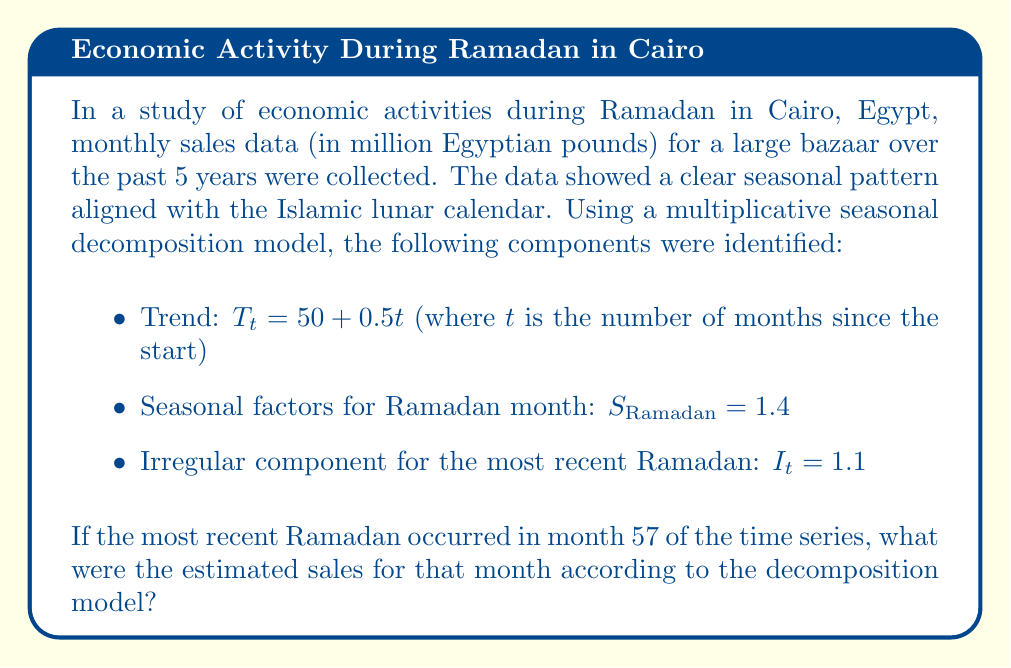Help me with this question. To solve this problem, we'll use the multiplicative seasonal decomposition model, which is represented as:

$$Y_t = T_t \times S_t \times I_t$$

Where:
$Y_t$ is the observed value
$T_t$ is the trend component
$S_t$ is the seasonal component
$I_t$ is the irregular component

Let's follow these steps:

1. Calculate the trend component for month 57:
   $$T_{57} = 50 + 0.5(57) = 50 + 28.5 = 78.5$$

2. We're given the seasonal factor for Ramadan:
   $$S_{\text{Ramadan}} = 1.4$$

3. The irregular component for this Ramadan is:
   $$I_{57} = 1.1$$

4. Now, let's multiply these components:
   $$Y_{57} = T_{57} \times S_{\text{Ramadan}} \times I_{57}$$
   $$Y_{57} = 78.5 \times 1.4 \times 1.1$$
   $$Y_{57} = 120.89$$

Therefore, the estimated sales for the most recent Ramadan month (month 57) were 120.89 million Egyptian pounds.
Answer: 120.89 million Egyptian pounds 